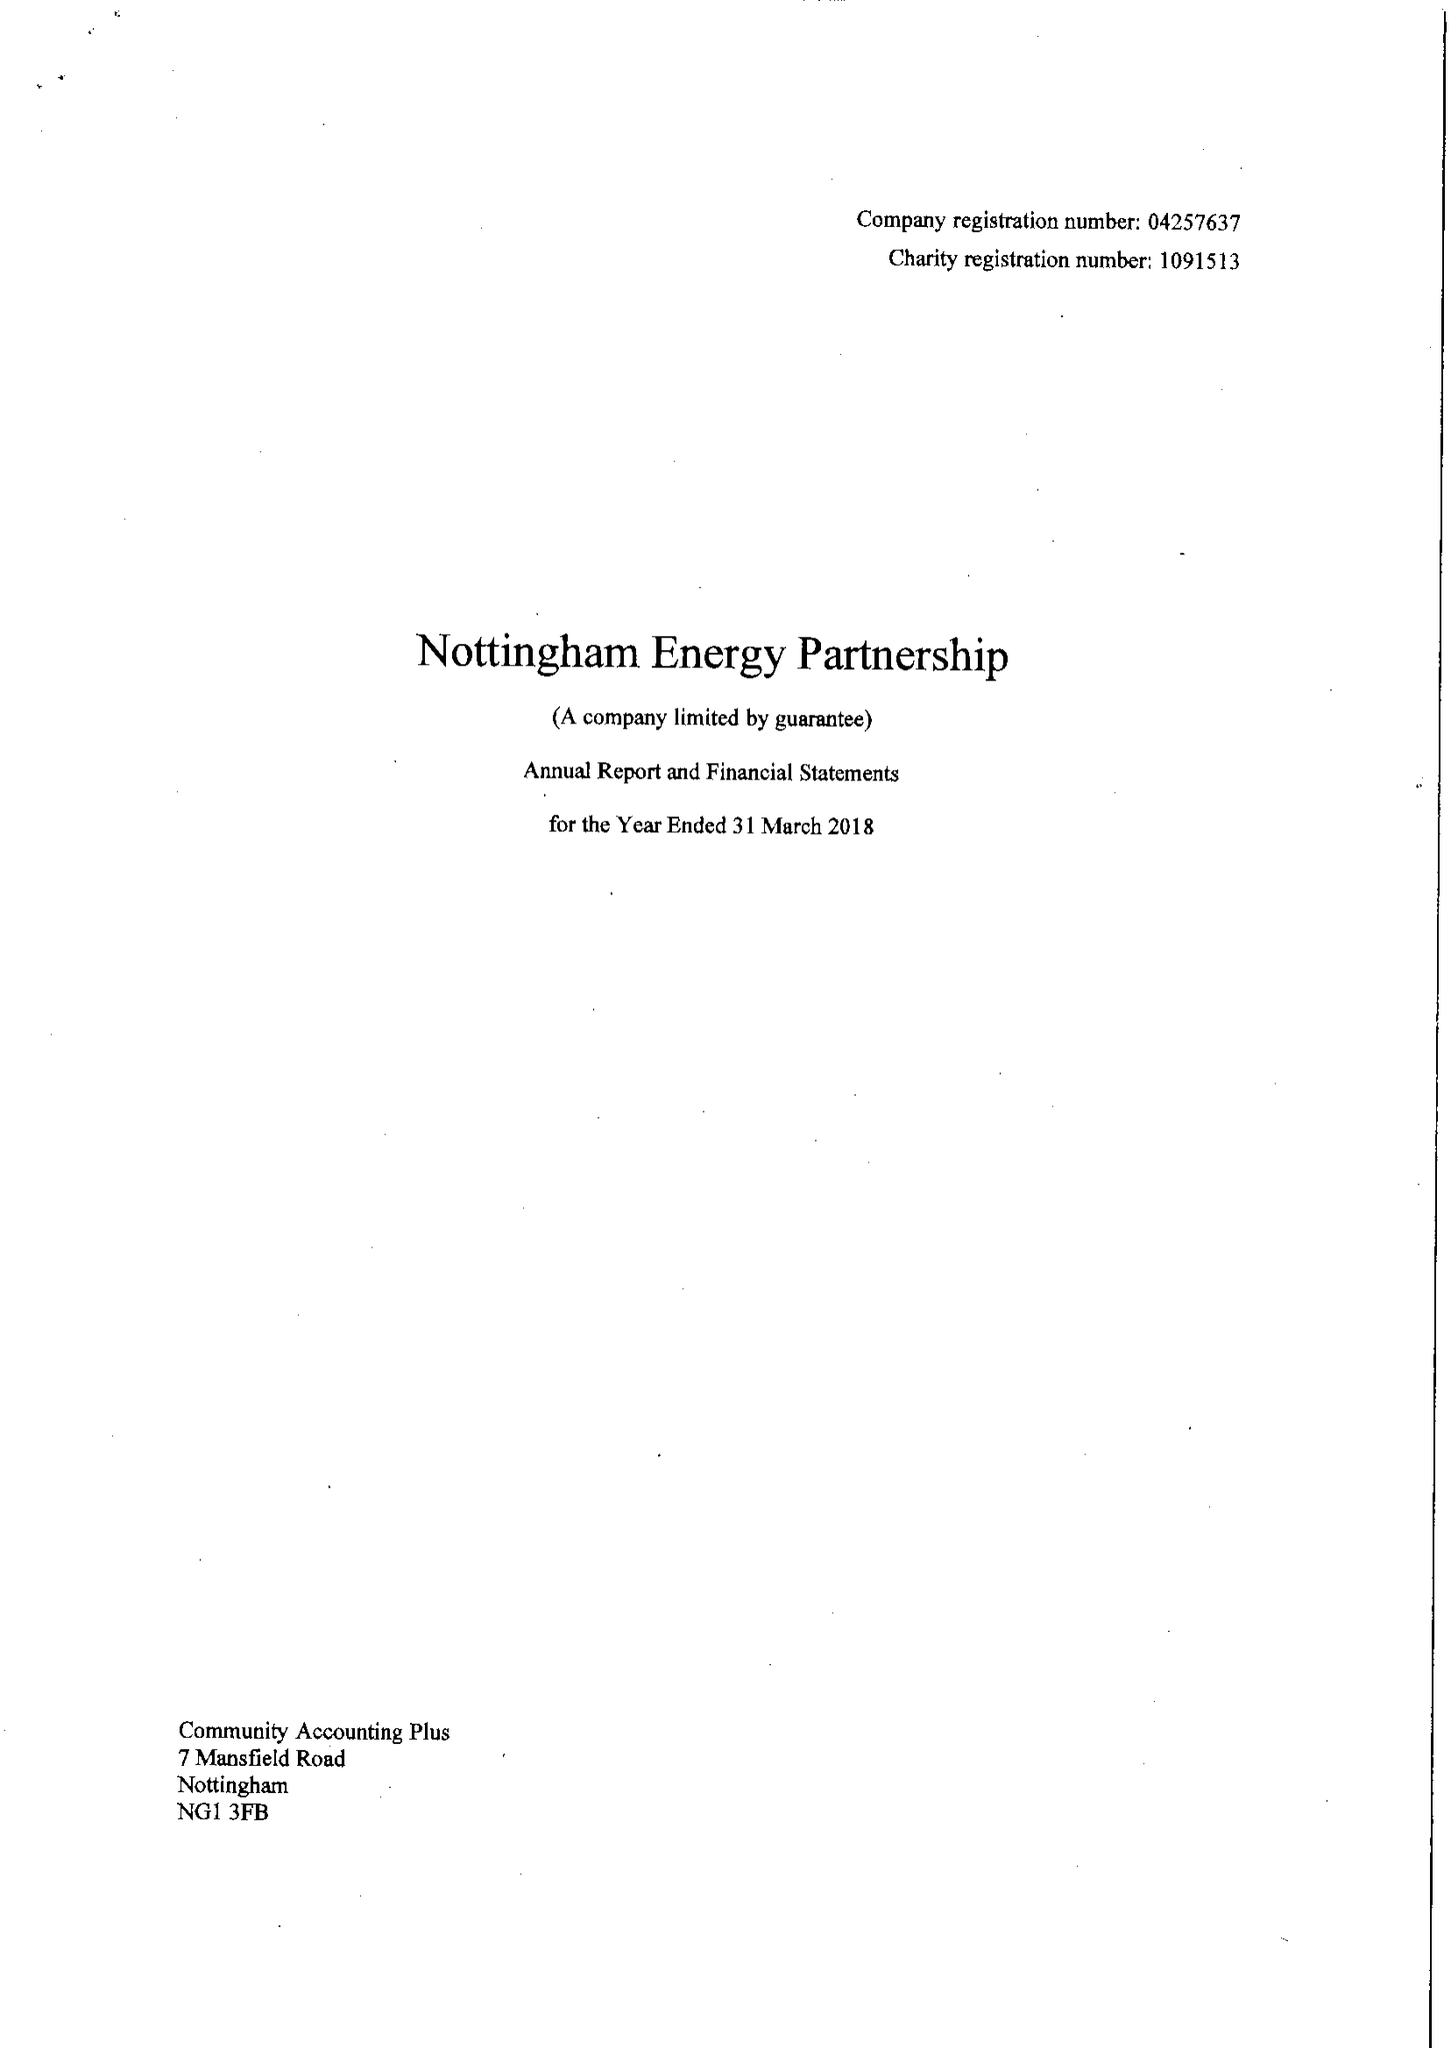What is the value for the report_date?
Answer the question using a single word or phrase. 2018-03-31 